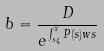<formula> <loc_0><loc_0><loc_500><loc_500>b = \frac { D } { e ^ { \int _ { s _ { 4 } } ^ { x } P ( s ) w s } }</formula> 